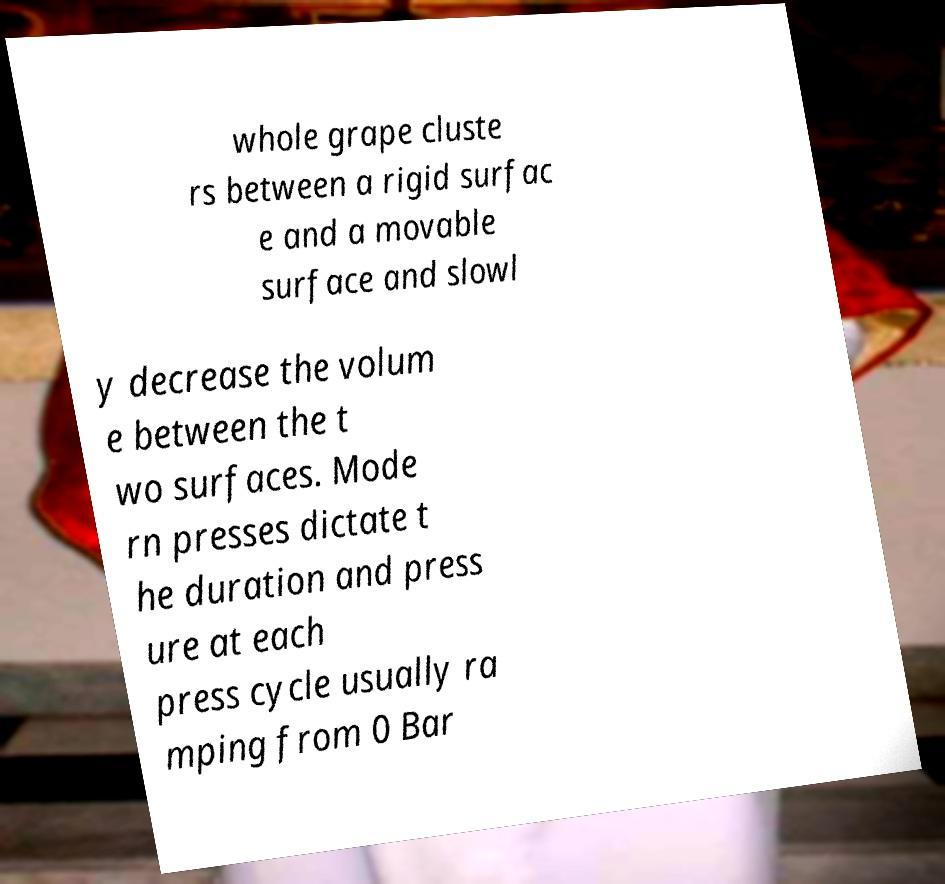I need the written content from this picture converted into text. Can you do that? whole grape cluste rs between a rigid surfac e and a movable surface and slowl y decrease the volum e between the t wo surfaces. Mode rn presses dictate t he duration and press ure at each press cycle usually ra mping from 0 Bar 